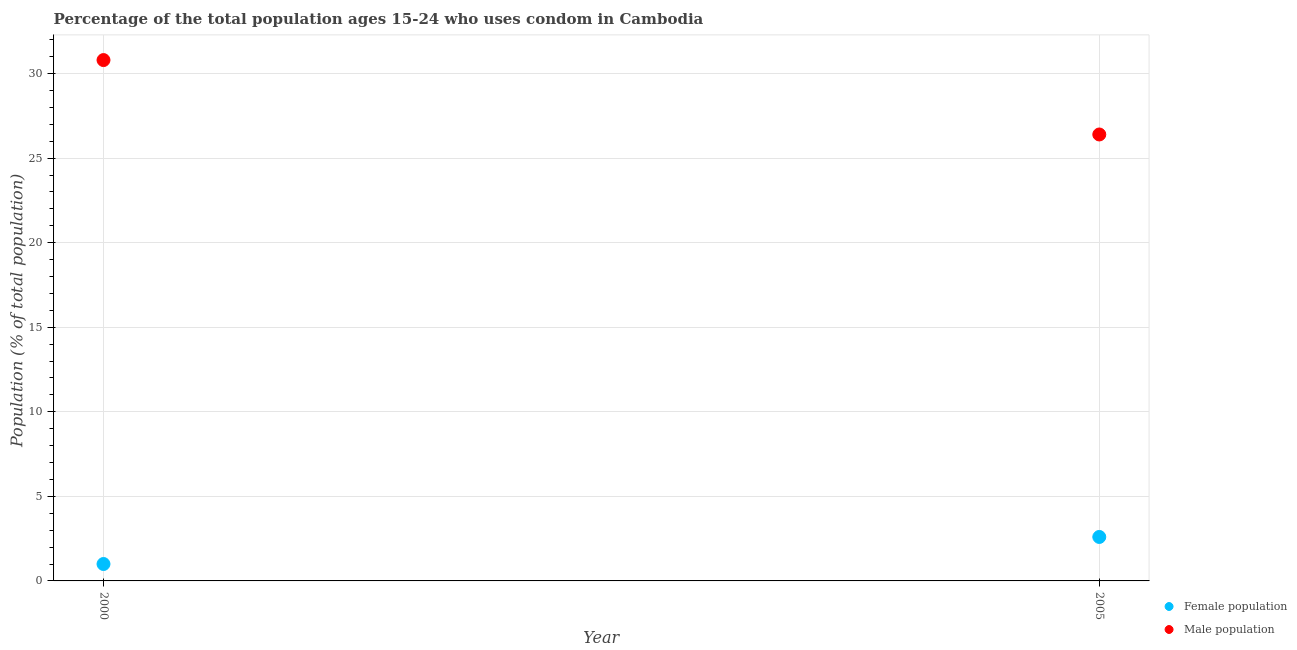What is the male population in 2005?
Ensure brevity in your answer.  26.4. Across all years, what is the minimum female population?
Give a very brief answer. 1. In which year was the female population maximum?
Offer a very short reply. 2005. What is the total male population in the graph?
Your answer should be compact. 57.2. What is the difference between the male population in 2000 and that in 2005?
Ensure brevity in your answer.  4.4. What is the difference between the male population in 2000 and the female population in 2005?
Provide a short and direct response. 28.2. What is the average male population per year?
Provide a succinct answer. 28.6. In the year 2005, what is the difference between the female population and male population?
Provide a short and direct response. -23.8. What is the ratio of the female population in 2000 to that in 2005?
Your answer should be compact. 0.38. Is the male population in 2000 less than that in 2005?
Keep it short and to the point. No. Does the female population monotonically increase over the years?
Provide a succinct answer. Yes. How many dotlines are there?
Provide a short and direct response. 2. What is the difference between two consecutive major ticks on the Y-axis?
Provide a succinct answer. 5. Are the values on the major ticks of Y-axis written in scientific E-notation?
Provide a short and direct response. No. Does the graph contain any zero values?
Make the answer very short. No. Where does the legend appear in the graph?
Your answer should be very brief. Bottom right. What is the title of the graph?
Your answer should be very brief. Percentage of the total population ages 15-24 who uses condom in Cambodia. Does "Nonresident" appear as one of the legend labels in the graph?
Ensure brevity in your answer.  No. What is the label or title of the X-axis?
Offer a terse response. Year. What is the label or title of the Y-axis?
Provide a short and direct response. Population (% of total population) . What is the Population (% of total population)  of Female population in 2000?
Ensure brevity in your answer.  1. What is the Population (% of total population)  in Male population in 2000?
Make the answer very short. 30.8. What is the Population (% of total population)  in Male population in 2005?
Make the answer very short. 26.4. Across all years, what is the maximum Population (% of total population)  in Female population?
Make the answer very short. 2.6. Across all years, what is the maximum Population (% of total population)  in Male population?
Provide a short and direct response. 30.8. Across all years, what is the minimum Population (% of total population)  in Male population?
Your answer should be very brief. 26.4. What is the total Population (% of total population)  of Male population in the graph?
Offer a very short reply. 57.2. What is the difference between the Population (% of total population)  of Male population in 2000 and that in 2005?
Your answer should be compact. 4.4. What is the difference between the Population (% of total population)  in Female population in 2000 and the Population (% of total population)  in Male population in 2005?
Offer a terse response. -25.4. What is the average Population (% of total population)  of Male population per year?
Provide a short and direct response. 28.6. In the year 2000, what is the difference between the Population (% of total population)  in Female population and Population (% of total population)  in Male population?
Offer a very short reply. -29.8. In the year 2005, what is the difference between the Population (% of total population)  of Female population and Population (% of total population)  of Male population?
Provide a short and direct response. -23.8. What is the ratio of the Population (% of total population)  of Female population in 2000 to that in 2005?
Keep it short and to the point. 0.38. What is the ratio of the Population (% of total population)  in Male population in 2000 to that in 2005?
Offer a very short reply. 1.17. What is the difference between the highest and the second highest Population (% of total population)  in Male population?
Offer a terse response. 4.4. What is the difference between the highest and the lowest Population (% of total population)  in Female population?
Provide a short and direct response. 1.6. What is the difference between the highest and the lowest Population (% of total population)  in Male population?
Provide a succinct answer. 4.4. 